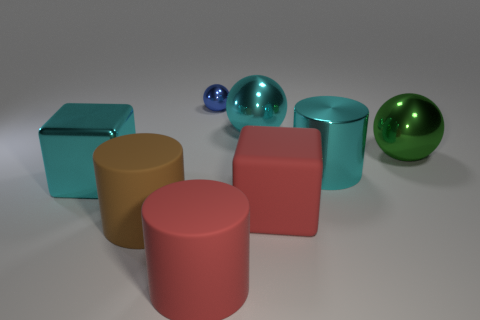Add 1 purple balls. How many objects exist? 9 Subtract all cylinders. How many objects are left? 5 Add 5 large matte cylinders. How many large matte cylinders exist? 7 Subtract 0 purple cylinders. How many objects are left? 8 Subtract all big purple cylinders. Subtract all large shiny spheres. How many objects are left? 6 Add 8 green metallic balls. How many green metallic balls are left? 9 